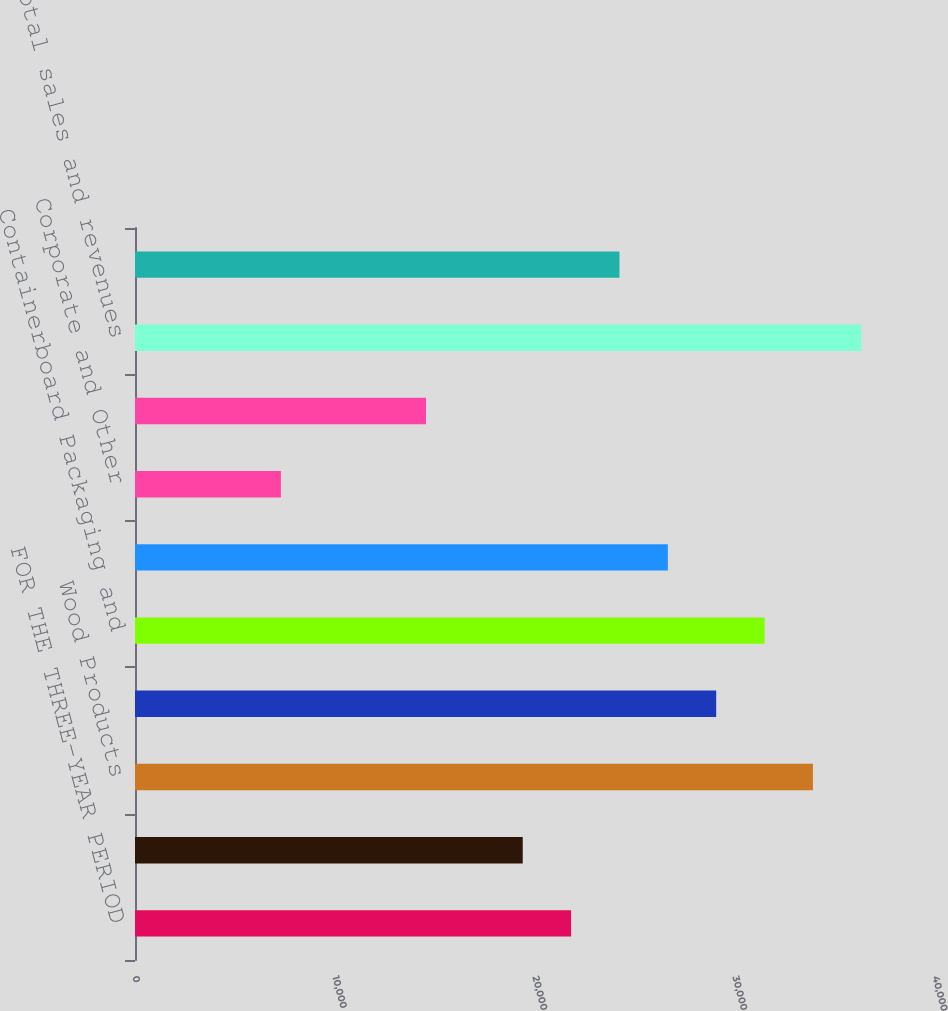<chart> <loc_0><loc_0><loc_500><loc_500><bar_chart><fcel>FOR THE THREE-YEAR PERIOD<fcel>Timberlands<fcel>Wood Products<fcel>Cellulose Fiber and White<fcel>Containerboard Packaging and<fcel>Real Estate and Related Assets<fcel>Corporate and Other<fcel>Less sales of discontinued<fcel>Total sales and revenues<fcel>Intersegment eliminations<nl><fcel>21804.7<fcel>19386.4<fcel>33896.2<fcel>29059.6<fcel>31477.9<fcel>26641.3<fcel>7294.9<fcel>14549.8<fcel>36314.5<fcel>24223<nl></chart> 